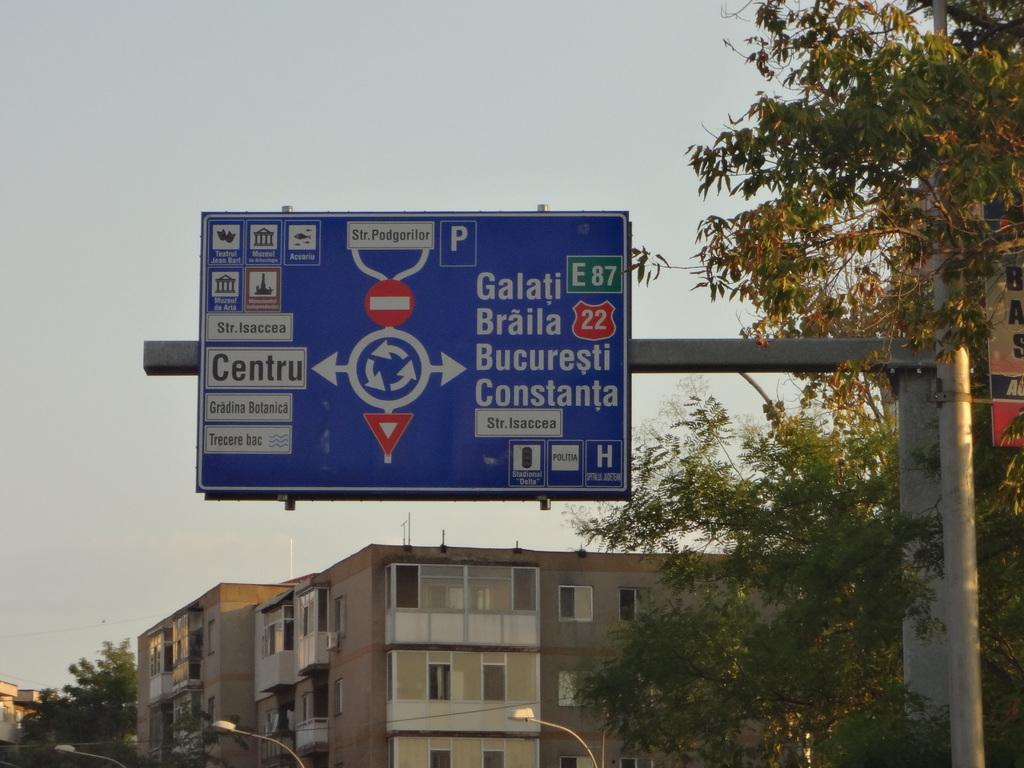<image>
Offer a succinct explanation of the picture presented. A street sign indicates that Centru is to the left. 